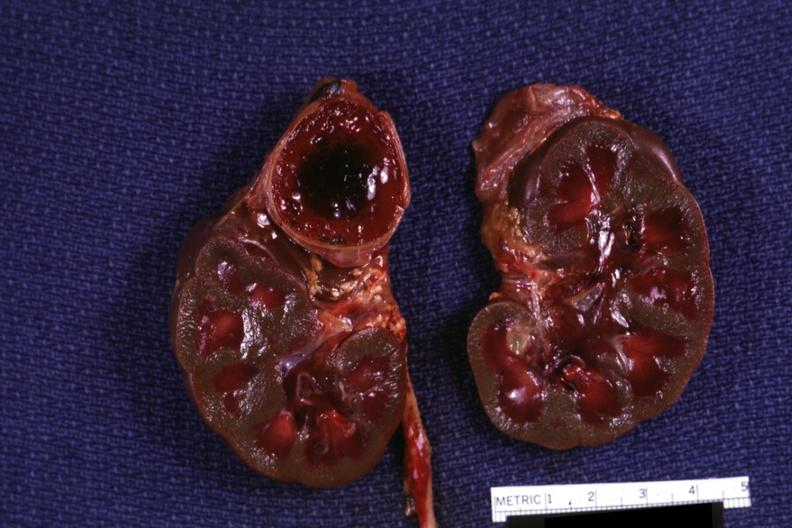does this image show section of both kidneys and adrenals hemorrhage on one side kidneys are jaundiced?
Answer the question using a single word or phrase. Yes 